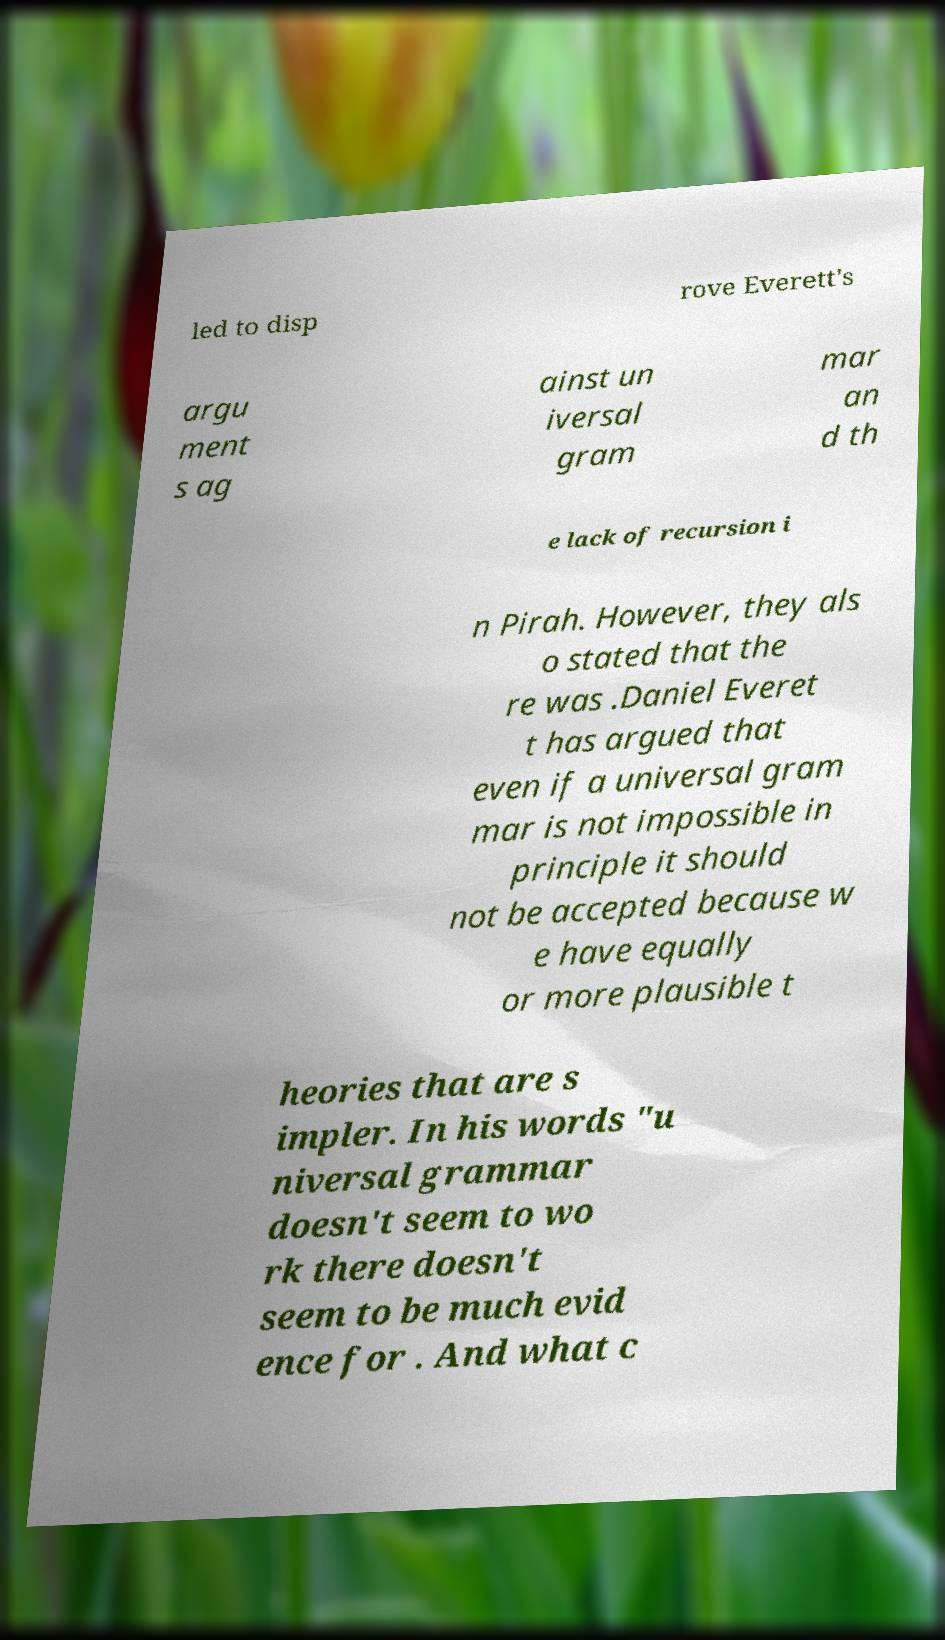What messages or text are displayed in this image? I need them in a readable, typed format. led to disp rove Everett's argu ment s ag ainst un iversal gram mar an d th e lack of recursion i n Pirah. However, they als o stated that the re was .Daniel Everet t has argued that even if a universal gram mar is not impossible in principle it should not be accepted because w e have equally or more plausible t heories that are s impler. In his words "u niversal grammar doesn't seem to wo rk there doesn't seem to be much evid ence for . And what c 